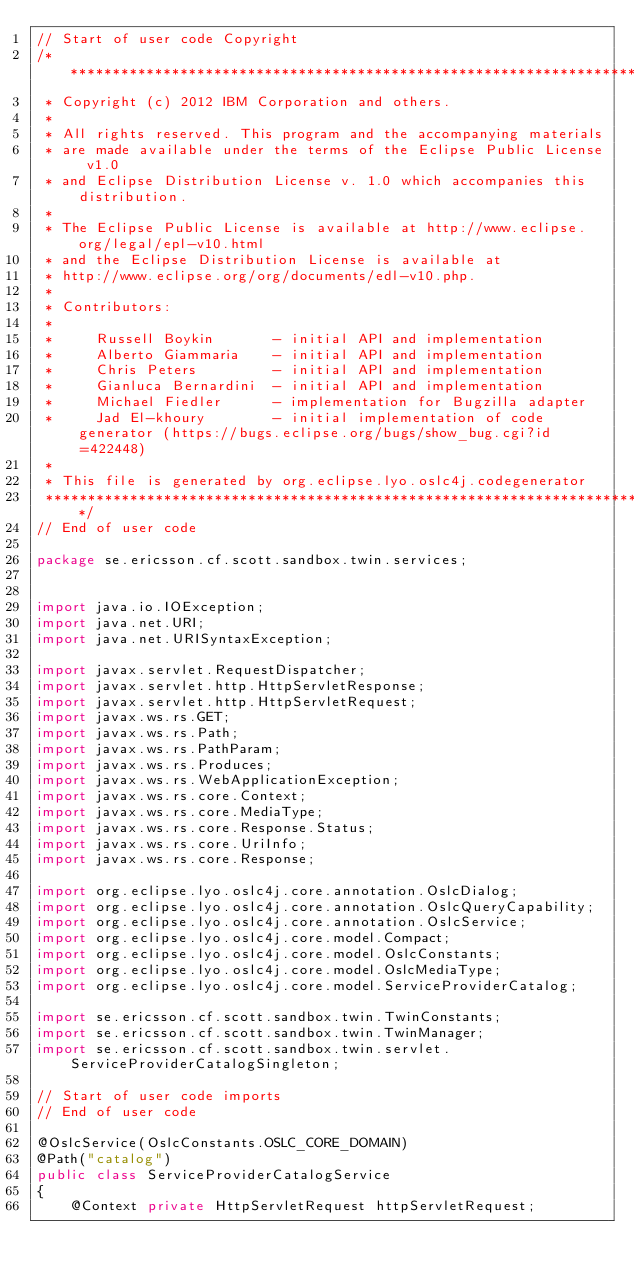Convert code to text. <code><loc_0><loc_0><loc_500><loc_500><_Java_>// Start of user code Copyright
/*******************************************************************************
 * Copyright (c) 2012 IBM Corporation and others.
 *
 * All rights reserved. This program and the accompanying materials
 * are made available under the terms of the Eclipse Public License v1.0
 * and Eclipse Distribution License v. 1.0 which accompanies this distribution.
 *
 * The Eclipse Public License is available at http://www.eclipse.org/legal/epl-v10.html
 * and the Eclipse Distribution License is available at
 * http://www.eclipse.org/org/documents/edl-v10.php.
 *
 * Contributors:
 *
 *     Russell Boykin       - initial API and implementation
 *     Alberto Giammaria    - initial API and implementation
 *     Chris Peters         - initial API and implementation
 *     Gianluca Bernardini  - initial API and implementation
 *     Michael Fiedler      - implementation for Bugzilla adapter
 *     Jad El-khoury        - initial implementation of code generator (https://bugs.eclipse.org/bugs/show_bug.cgi?id=422448)
 *
 * This file is generated by org.eclipse.lyo.oslc4j.codegenerator
 *******************************************************************************/
// End of user code

package se.ericsson.cf.scott.sandbox.twin.services;


import java.io.IOException;
import java.net.URI;
import java.net.URISyntaxException;

import javax.servlet.RequestDispatcher;
import javax.servlet.http.HttpServletResponse;
import javax.servlet.http.HttpServletRequest;
import javax.ws.rs.GET;
import javax.ws.rs.Path;
import javax.ws.rs.PathParam;
import javax.ws.rs.Produces;
import javax.ws.rs.WebApplicationException;
import javax.ws.rs.core.Context;
import javax.ws.rs.core.MediaType;
import javax.ws.rs.core.Response.Status;
import javax.ws.rs.core.UriInfo;
import javax.ws.rs.core.Response;

import org.eclipse.lyo.oslc4j.core.annotation.OslcDialog;
import org.eclipse.lyo.oslc4j.core.annotation.OslcQueryCapability;
import org.eclipse.lyo.oslc4j.core.annotation.OslcService;
import org.eclipse.lyo.oslc4j.core.model.Compact;
import org.eclipse.lyo.oslc4j.core.model.OslcConstants;
import org.eclipse.lyo.oslc4j.core.model.OslcMediaType;
import org.eclipse.lyo.oslc4j.core.model.ServiceProviderCatalog;

import se.ericsson.cf.scott.sandbox.twin.TwinConstants;
import se.ericsson.cf.scott.sandbox.twin.TwinManager;
import se.ericsson.cf.scott.sandbox.twin.servlet.ServiceProviderCatalogSingleton;

// Start of user code imports
// End of user code

@OslcService(OslcConstants.OSLC_CORE_DOMAIN)
@Path("catalog")
public class ServiceProviderCatalogService
{
    @Context private HttpServletRequest httpServletRequest;</code> 